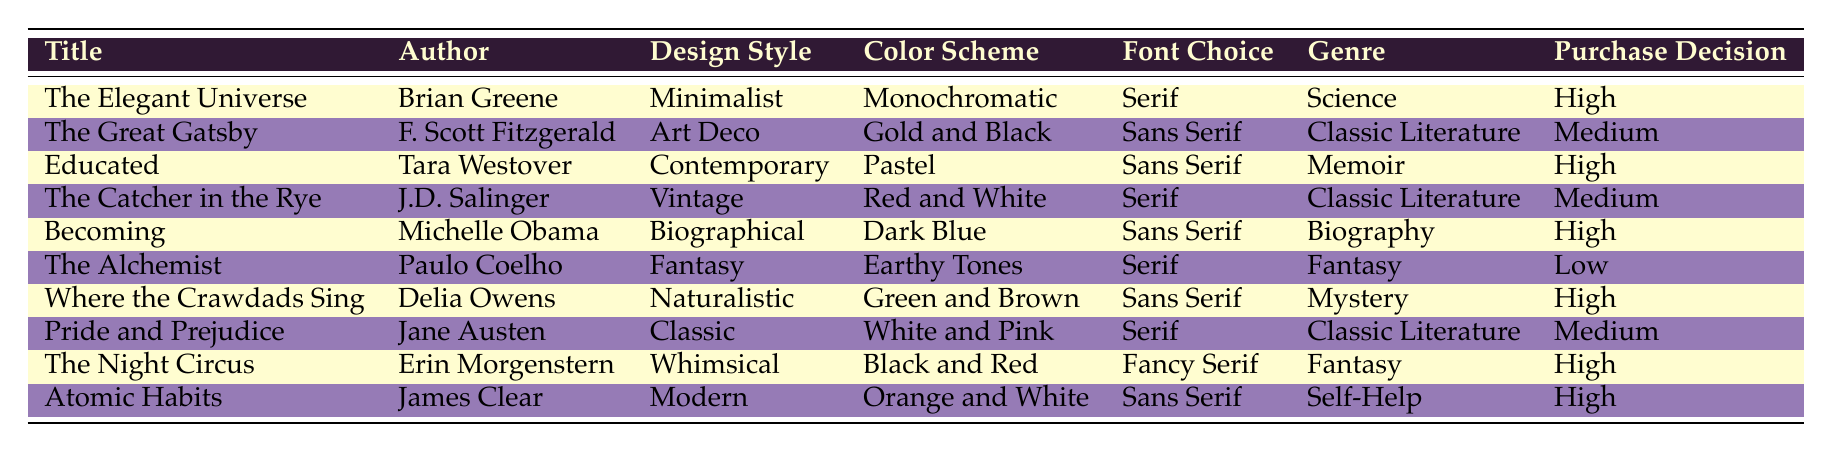What is the purchase decision for "Where the Crawdads Sing"? Referring to the table, "Where the Crawdads Sing" has a purchase decision classified as "High".
Answer: High How many books have a purchase decision of "Medium"? Looking at the table, the books with a "Medium" purchase decision are "The Great Gatsby", "The Catcher in the Rye", and "Pride and Prejudice", making a total of 3 books.
Answer: 3 True or False: "The Alchemist" has a serif font choice. The table indicates that "The Alchemist" has a "Serif" font choice, confirming the statement is true.
Answer: True Which design style has the highest number of books associated with it, and how many are there? By examining the table, the design styles of "Minimalist", "Art Deco", "Contemporary", "Vintage", "Biographical", "Fantasy", "Naturalistic", "Classic", "Whimsical", and "Modern" are all unique, suggesting a maximum of one book per style. Therefore, no style has more than one book associated with it; each design style corresponds to one distinct title.
Answer: 1 What is the average purchase decision level for books designed in "Fantasy"? There are two books with the "Fantasy" design, namely "The Alchemist" (Low) and "The Night Circus" (High). We can assign numerical values to purchase decisions: Low = 1, Medium = 2, High = 3; thus the average is (1 + 3) / 2 = 2 which corresponds to "Medium".
Answer: Medium 